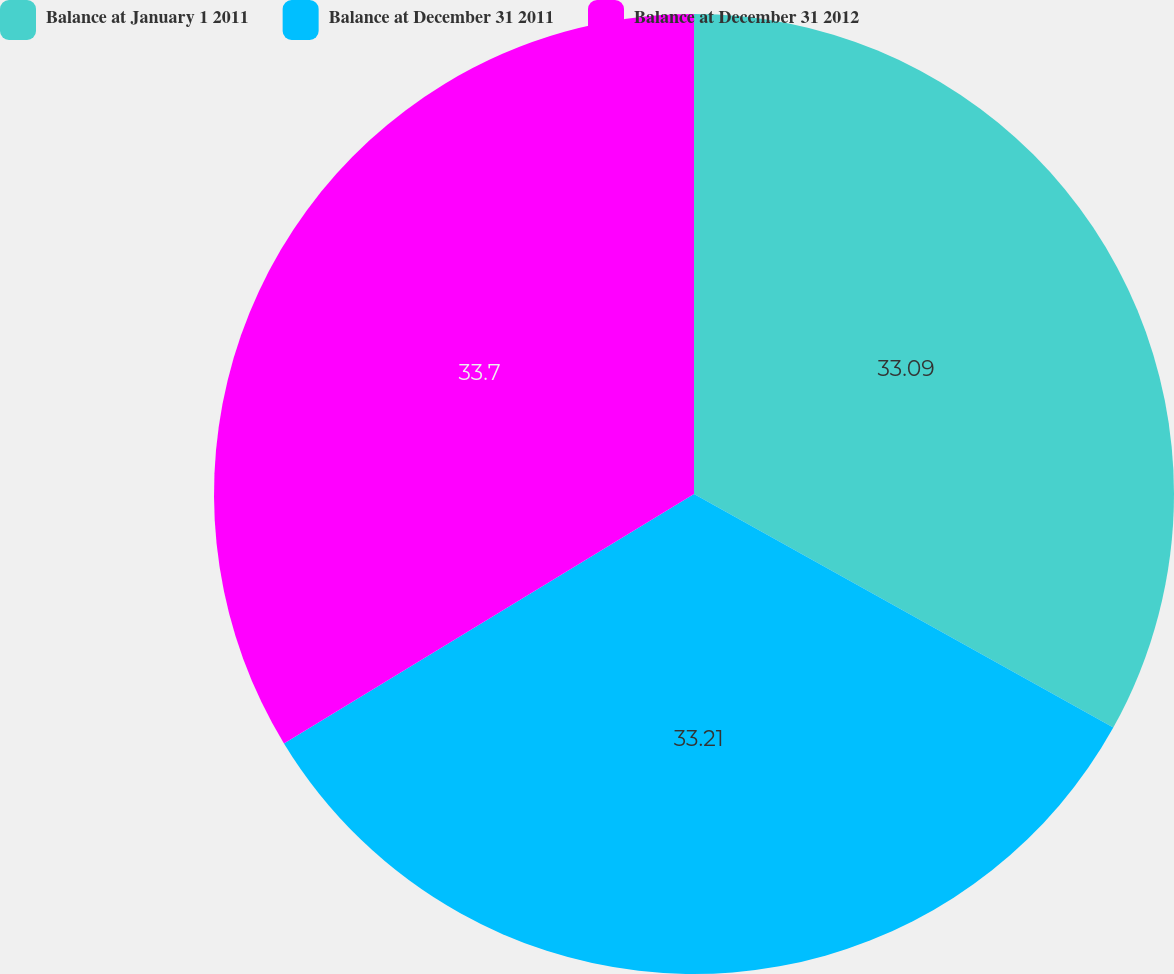Convert chart to OTSL. <chart><loc_0><loc_0><loc_500><loc_500><pie_chart><fcel>Balance at January 1 2011<fcel>Balance at December 31 2011<fcel>Balance at December 31 2012<nl><fcel>33.09%<fcel>33.21%<fcel>33.7%<nl></chart> 